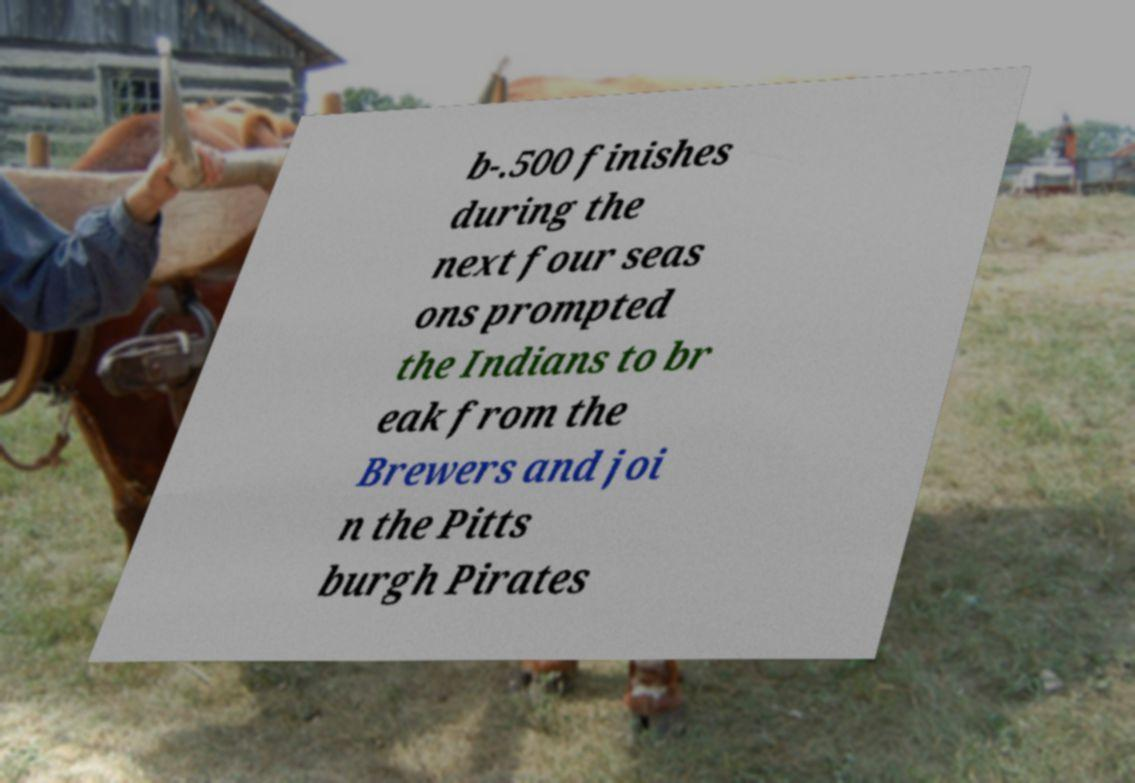Can you read and provide the text displayed in the image?This photo seems to have some interesting text. Can you extract and type it out for me? b-.500 finishes during the next four seas ons prompted the Indians to br eak from the Brewers and joi n the Pitts burgh Pirates 